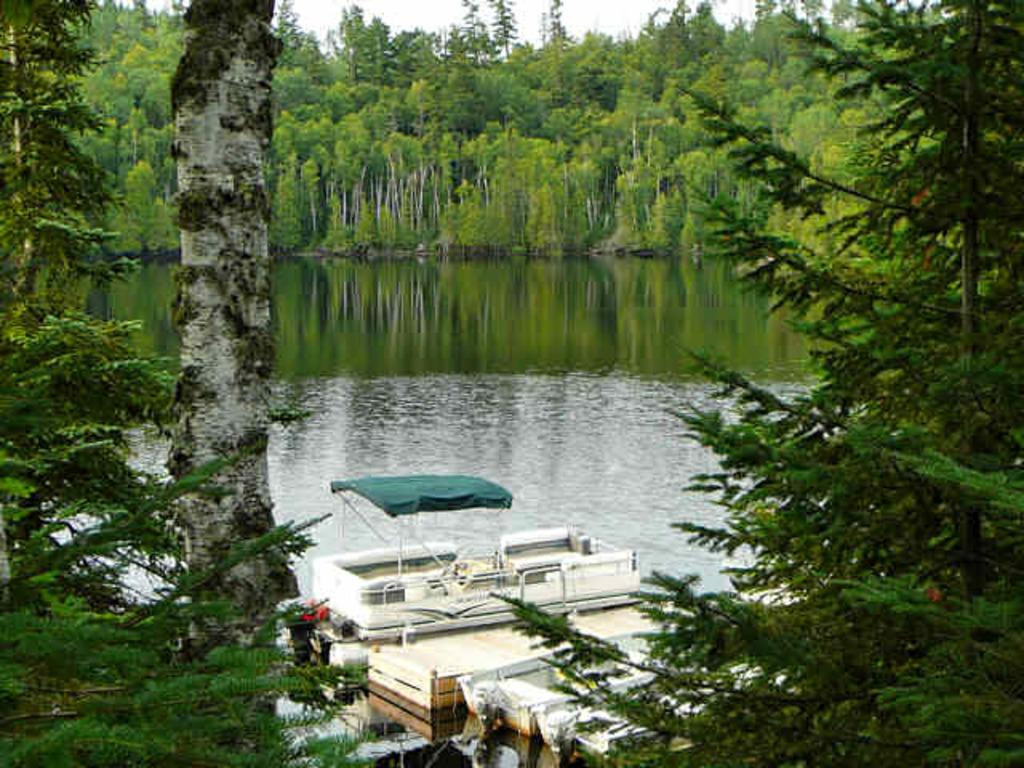What type of vegetation can be seen in the image? There are trees in the image. What body of water is present in the image? There is a river at the center of the image. What type of vehicles can be seen at the bottom of the image? There are ships at the bottom of the image. How many slaves are visible in the image? There are no slaves present in the image. What form does the river take in the image? The river is depicted as a body of water in the image, but it does not have a specific form. 